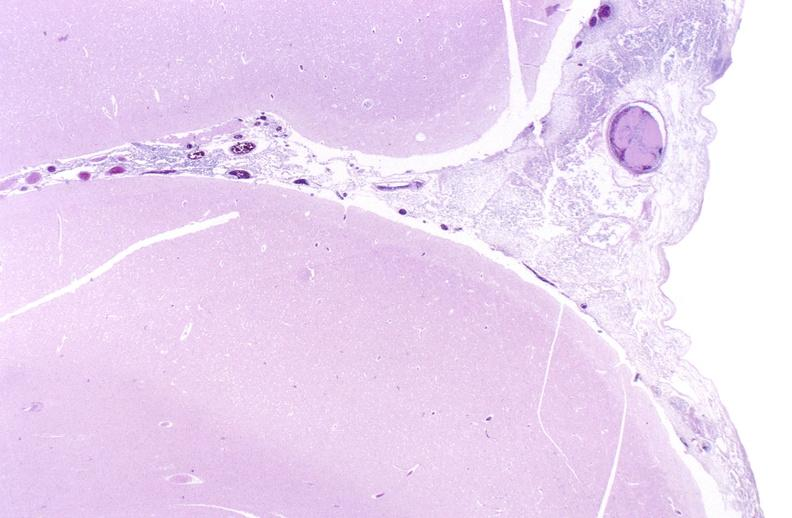does this image show bacterial meningitis?
Answer the question using a single word or phrase. Yes 